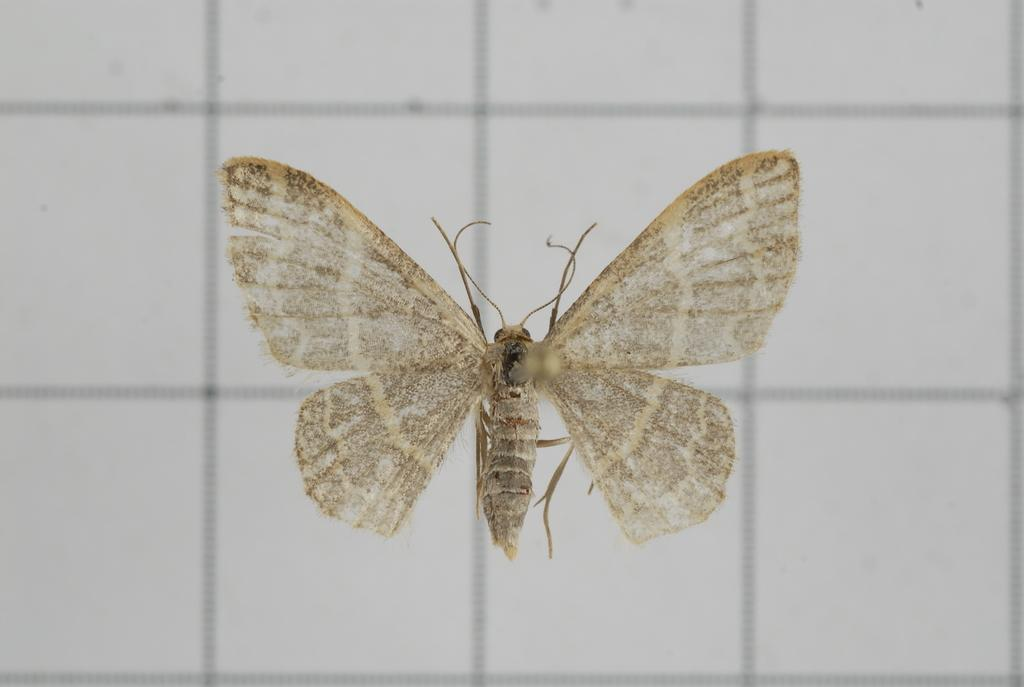What is the main subject of the image? There is a butterfly in the image. Where is the butterfly located? The butterfly is on the wall. How many islands can be seen in the image? There are no islands present in the image; it features a butterfly on a wall. What type of unit is the butterfly associated with in the image? There is no unit mentioned or implied in the image; it simply shows a butterfly on a wall. 